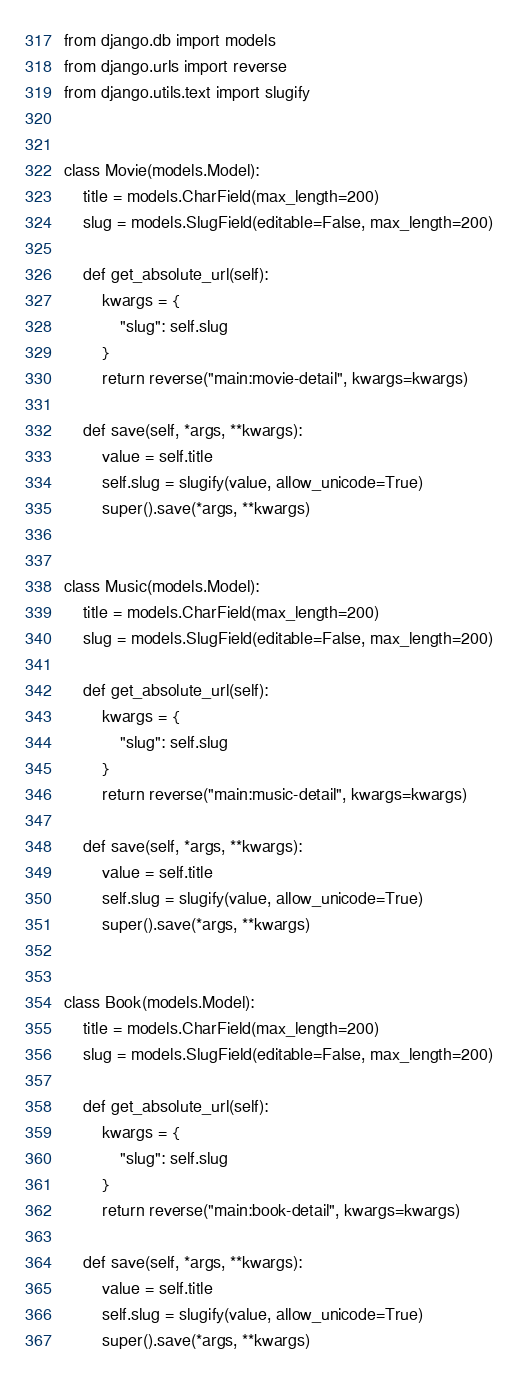Convert code to text. <code><loc_0><loc_0><loc_500><loc_500><_Python_>from django.db import models
from django.urls import reverse
from django.utils.text import slugify


class Movie(models.Model):
    title = models.CharField(max_length=200)
    slug = models.SlugField(editable=False, max_length=200)

    def get_absolute_url(self):
        kwargs = {
            "slug": self.slug
        }
        return reverse("main:movie-detail", kwargs=kwargs)

    def save(self, *args, **kwargs):
        value = self.title
        self.slug = slugify(value, allow_unicode=True)
        super().save(*args, **kwargs)


class Music(models.Model):
    title = models.CharField(max_length=200)
    slug = models.SlugField(editable=False, max_length=200)

    def get_absolute_url(self):
        kwargs = {
            "slug": self.slug
        }
        return reverse("main:music-detail", kwargs=kwargs)

    def save(self, *args, **kwargs):
        value = self.title
        self.slug = slugify(value, allow_unicode=True)
        super().save(*args, **kwargs)


class Book(models.Model):
    title = models.CharField(max_length=200)
    slug = models.SlugField(editable=False, max_length=200)

    def get_absolute_url(self):
        kwargs = {
            "slug": self.slug
        }
        return reverse("main:book-detail", kwargs=kwargs)

    def save(self, *args, **kwargs):
        value = self.title
        self.slug = slugify(value, allow_unicode=True)
        super().save(*args, **kwargs)
</code> 